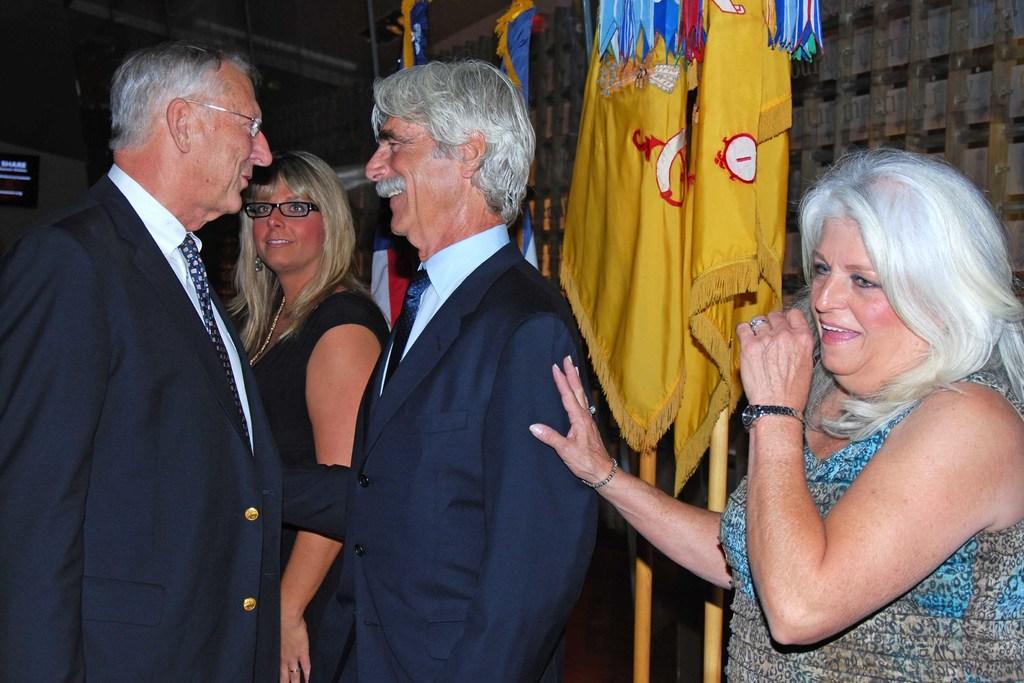Describe this image in one or two sentences. In this picture I can see few people standing and we see couple of men talking to each other and we see few flags on the back and I can see a woman holding a man with the hand and I can see couple of them wore spectacles. 